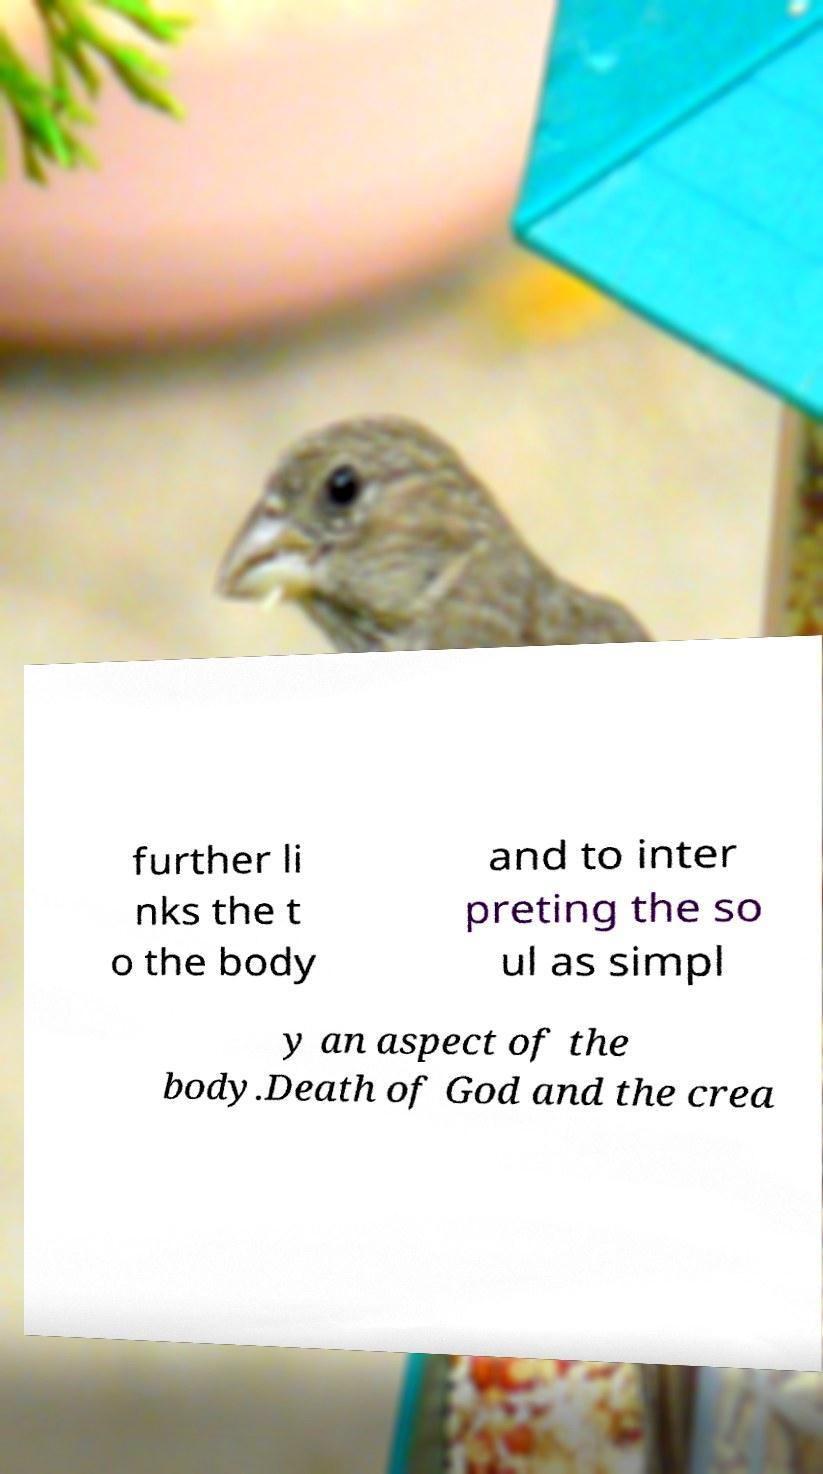There's text embedded in this image that I need extracted. Can you transcribe it verbatim? further li nks the t o the body and to inter preting the so ul as simpl y an aspect of the body.Death of God and the crea 